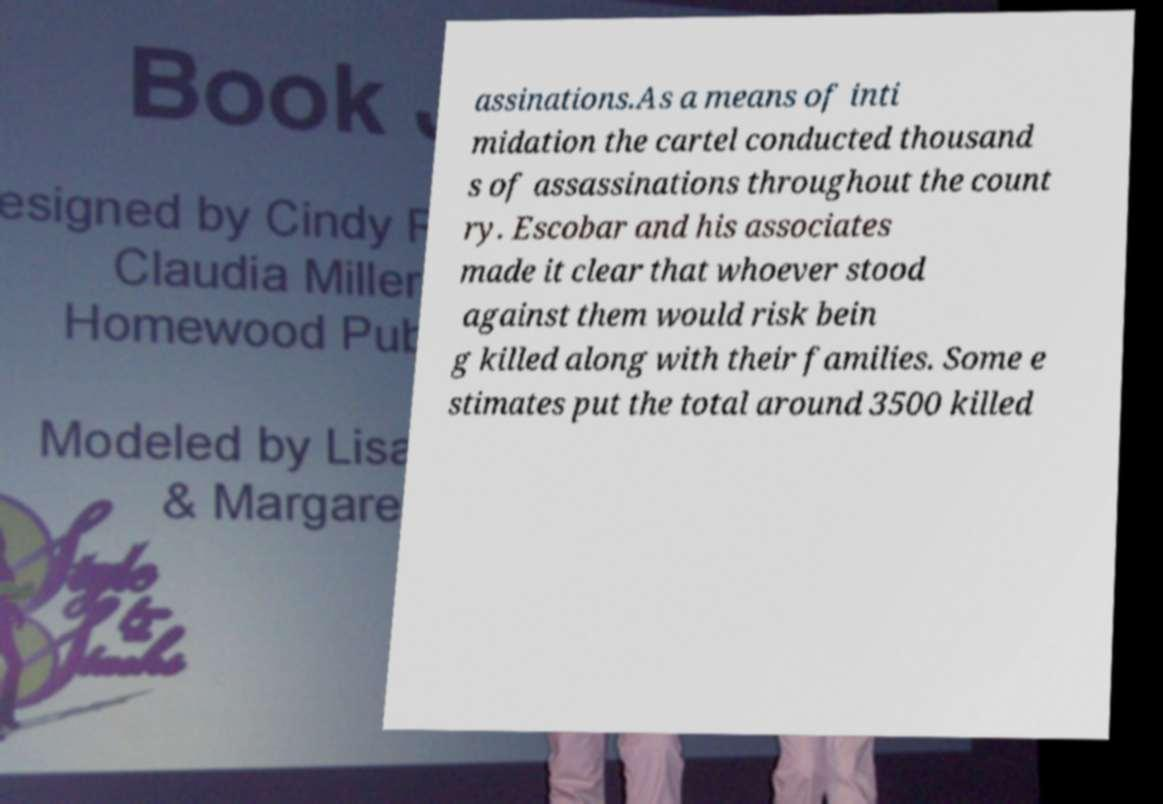Please identify and transcribe the text found in this image. assinations.As a means of inti midation the cartel conducted thousand s of assassinations throughout the count ry. Escobar and his associates made it clear that whoever stood against them would risk bein g killed along with their families. Some e stimates put the total around 3500 killed 